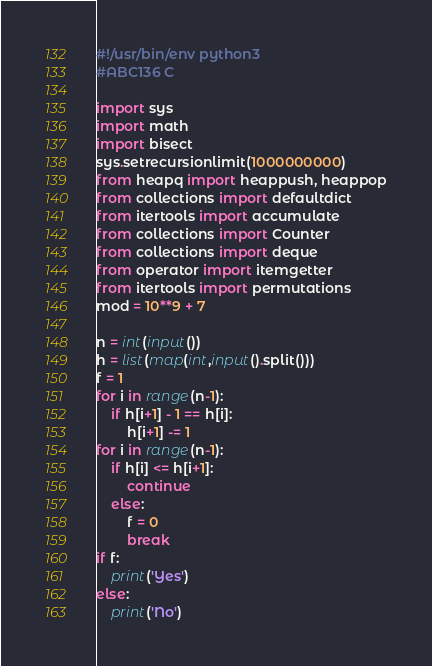Convert code to text. <code><loc_0><loc_0><loc_500><loc_500><_Python_>#!/usr/bin/env python3
#ABC136 C

import sys
import math
import bisect
sys.setrecursionlimit(1000000000)
from heapq import heappush, heappop
from collections import defaultdict
from itertools import accumulate
from collections import Counter
from collections import deque
from operator import itemgetter
from itertools import permutations
mod = 10**9 + 7

n = int(input())
h = list(map(int,input().split()))
f = 1
for i in range(n-1):
    if h[i+1] - 1 == h[i]:
        h[i+1] -= 1
for i in range(n-1):
    if h[i] <= h[i+1]:
        continue
    else:
        f = 0
        break
if f:
    print('Yes')
else:
    print('No')
</code> 